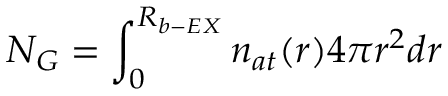<formula> <loc_0><loc_0><loc_500><loc_500>N _ { G } = \int _ { 0 } ^ { R _ { b - E X } } n _ { a t } ( r ) 4 \pi r ^ { 2 } d r</formula> 